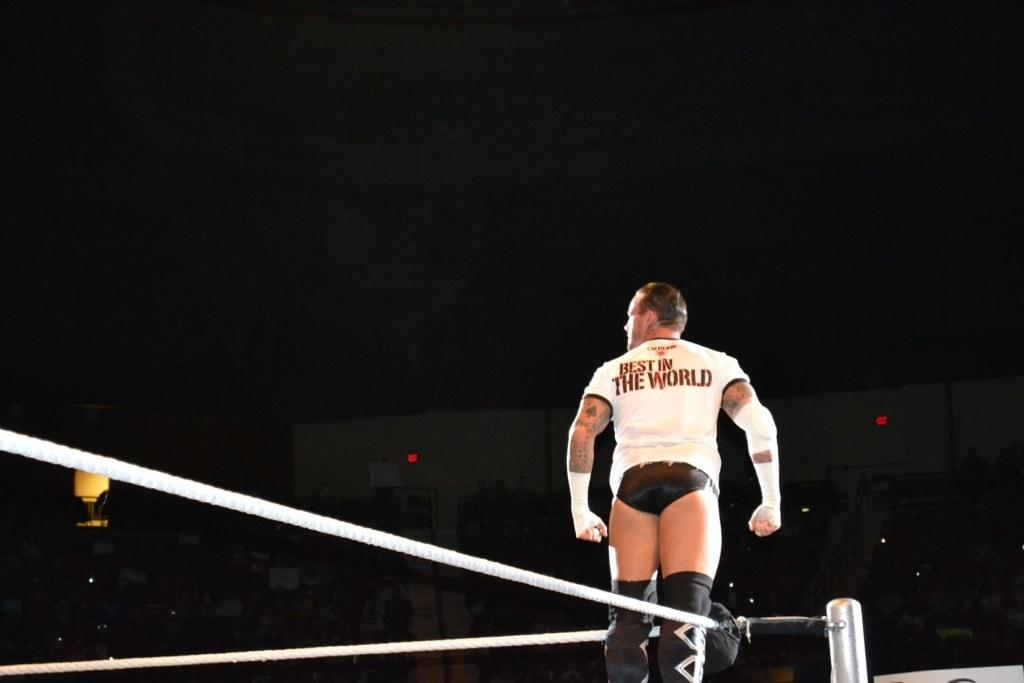<image>
Create a compact narrative representing the image presented. A wrestler has a shirt with the phrase best in the world on the back. 